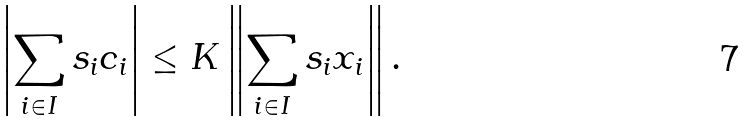Convert formula to latex. <formula><loc_0><loc_0><loc_500><loc_500>\left | \sum _ { i \in I } s _ { i } c _ { i } \right | \leq K \left \| \sum _ { i \in I } s _ { i } x _ { i } \right \| .</formula> 